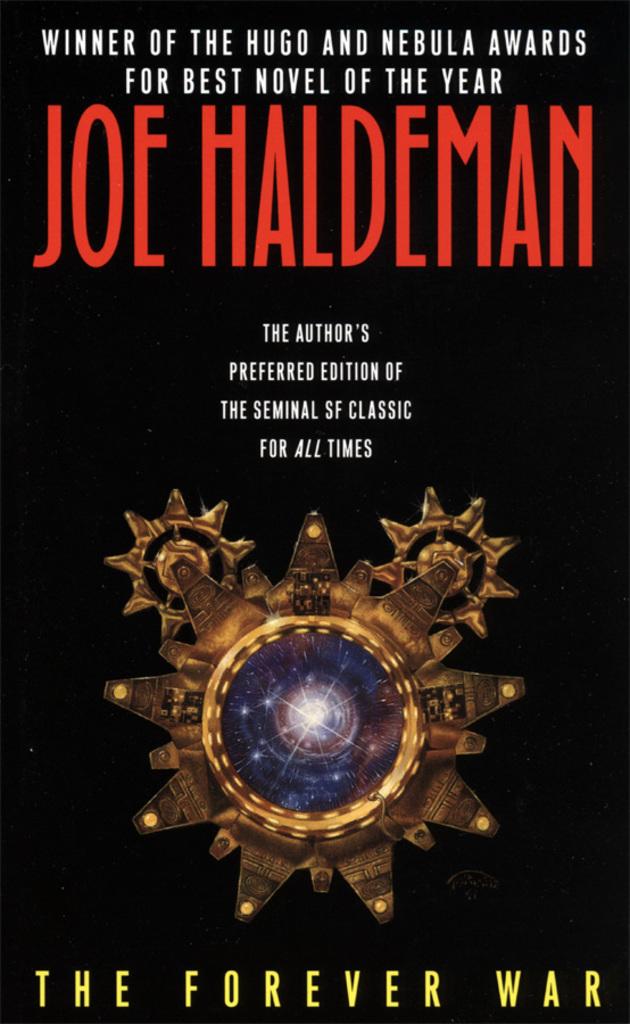Who wrote the book?
Make the answer very short. Joe haldeman. 